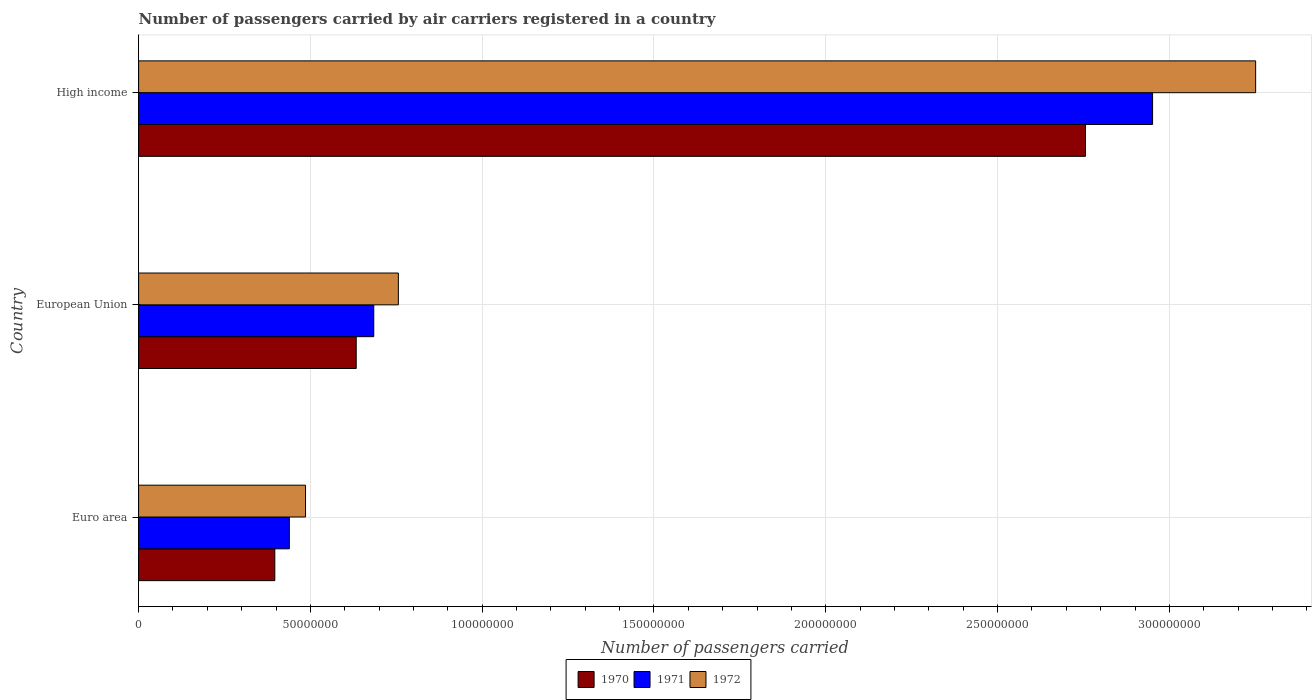How many groups of bars are there?
Provide a succinct answer. 3. Are the number of bars on each tick of the Y-axis equal?
Provide a succinct answer. Yes. How many bars are there on the 2nd tick from the top?
Give a very brief answer. 3. How many bars are there on the 3rd tick from the bottom?
Make the answer very short. 3. What is the label of the 2nd group of bars from the top?
Your answer should be compact. European Union. In how many cases, is the number of bars for a given country not equal to the number of legend labels?
Give a very brief answer. 0. What is the number of passengers carried by air carriers in 1972 in High income?
Ensure brevity in your answer.  3.25e+08. Across all countries, what is the maximum number of passengers carried by air carriers in 1972?
Provide a succinct answer. 3.25e+08. Across all countries, what is the minimum number of passengers carried by air carriers in 1971?
Your response must be concise. 4.39e+07. In which country was the number of passengers carried by air carriers in 1972 maximum?
Your answer should be very brief. High income. In which country was the number of passengers carried by air carriers in 1970 minimum?
Your response must be concise. Euro area. What is the total number of passengers carried by air carriers in 1970 in the graph?
Provide a succinct answer. 3.79e+08. What is the difference between the number of passengers carried by air carriers in 1971 in Euro area and that in High income?
Offer a very short reply. -2.51e+08. What is the difference between the number of passengers carried by air carriers in 1972 in European Union and the number of passengers carried by air carriers in 1971 in High income?
Ensure brevity in your answer.  -2.20e+08. What is the average number of passengers carried by air carriers in 1971 per country?
Provide a succinct answer. 1.36e+08. What is the difference between the number of passengers carried by air carriers in 1970 and number of passengers carried by air carriers in 1971 in High income?
Give a very brief answer. -1.95e+07. What is the ratio of the number of passengers carried by air carriers in 1971 in Euro area to that in High income?
Make the answer very short. 0.15. Is the number of passengers carried by air carriers in 1972 in European Union less than that in High income?
Your answer should be compact. Yes. What is the difference between the highest and the second highest number of passengers carried by air carriers in 1972?
Provide a succinct answer. 2.50e+08. What is the difference between the highest and the lowest number of passengers carried by air carriers in 1971?
Provide a short and direct response. 2.51e+08. What does the 1st bar from the top in Euro area represents?
Give a very brief answer. 1972. What does the 2nd bar from the bottom in High income represents?
Your response must be concise. 1971. Is it the case that in every country, the sum of the number of passengers carried by air carriers in 1970 and number of passengers carried by air carriers in 1972 is greater than the number of passengers carried by air carriers in 1971?
Provide a succinct answer. Yes. Does the graph contain grids?
Provide a succinct answer. Yes. How many legend labels are there?
Your response must be concise. 3. What is the title of the graph?
Your response must be concise. Number of passengers carried by air carriers registered in a country. Does "1983" appear as one of the legend labels in the graph?
Your answer should be compact. No. What is the label or title of the X-axis?
Keep it short and to the point. Number of passengers carried. What is the Number of passengers carried of 1970 in Euro area?
Offer a terse response. 3.96e+07. What is the Number of passengers carried of 1971 in Euro area?
Provide a succinct answer. 4.39e+07. What is the Number of passengers carried of 1972 in Euro area?
Keep it short and to the point. 4.86e+07. What is the Number of passengers carried in 1970 in European Union?
Give a very brief answer. 6.33e+07. What is the Number of passengers carried in 1971 in European Union?
Provide a succinct answer. 6.84e+07. What is the Number of passengers carried of 1972 in European Union?
Your answer should be very brief. 7.56e+07. What is the Number of passengers carried in 1970 in High income?
Keep it short and to the point. 2.76e+08. What is the Number of passengers carried of 1971 in High income?
Provide a succinct answer. 2.95e+08. What is the Number of passengers carried in 1972 in High income?
Offer a terse response. 3.25e+08. Across all countries, what is the maximum Number of passengers carried in 1970?
Provide a short and direct response. 2.76e+08. Across all countries, what is the maximum Number of passengers carried of 1971?
Ensure brevity in your answer.  2.95e+08. Across all countries, what is the maximum Number of passengers carried of 1972?
Offer a very short reply. 3.25e+08. Across all countries, what is the minimum Number of passengers carried in 1970?
Keep it short and to the point. 3.96e+07. Across all countries, what is the minimum Number of passengers carried of 1971?
Give a very brief answer. 4.39e+07. Across all countries, what is the minimum Number of passengers carried in 1972?
Provide a succinct answer. 4.86e+07. What is the total Number of passengers carried of 1970 in the graph?
Your answer should be compact. 3.79e+08. What is the total Number of passengers carried of 1971 in the graph?
Your response must be concise. 4.07e+08. What is the total Number of passengers carried of 1972 in the graph?
Give a very brief answer. 4.49e+08. What is the difference between the Number of passengers carried of 1970 in Euro area and that in European Union?
Your answer should be very brief. -2.37e+07. What is the difference between the Number of passengers carried in 1971 in Euro area and that in European Union?
Give a very brief answer. -2.46e+07. What is the difference between the Number of passengers carried in 1972 in Euro area and that in European Union?
Offer a very short reply. -2.70e+07. What is the difference between the Number of passengers carried in 1970 in Euro area and that in High income?
Make the answer very short. -2.36e+08. What is the difference between the Number of passengers carried of 1971 in Euro area and that in High income?
Offer a very short reply. -2.51e+08. What is the difference between the Number of passengers carried in 1972 in Euro area and that in High income?
Your answer should be compact. -2.77e+08. What is the difference between the Number of passengers carried of 1970 in European Union and that in High income?
Your answer should be compact. -2.12e+08. What is the difference between the Number of passengers carried of 1971 in European Union and that in High income?
Your response must be concise. -2.27e+08. What is the difference between the Number of passengers carried of 1972 in European Union and that in High income?
Offer a very short reply. -2.50e+08. What is the difference between the Number of passengers carried of 1970 in Euro area and the Number of passengers carried of 1971 in European Union?
Offer a terse response. -2.88e+07. What is the difference between the Number of passengers carried in 1970 in Euro area and the Number of passengers carried in 1972 in European Union?
Ensure brevity in your answer.  -3.60e+07. What is the difference between the Number of passengers carried in 1971 in Euro area and the Number of passengers carried in 1972 in European Union?
Give a very brief answer. -3.17e+07. What is the difference between the Number of passengers carried in 1970 in Euro area and the Number of passengers carried in 1971 in High income?
Ensure brevity in your answer.  -2.55e+08. What is the difference between the Number of passengers carried of 1970 in Euro area and the Number of passengers carried of 1972 in High income?
Your answer should be very brief. -2.85e+08. What is the difference between the Number of passengers carried of 1971 in Euro area and the Number of passengers carried of 1972 in High income?
Provide a succinct answer. -2.81e+08. What is the difference between the Number of passengers carried in 1970 in European Union and the Number of passengers carried in 1971 in High income?
Keep it short and to the point. -2.32e+08. What is the difference between the Number of passengers carried in 1970 in European Union and the Number of passengers carried in 1972 in High income?
Your answer should be very brief. -2.62e+08. What is the difference between the Number of passengers carried in 1971 in European Union and the Number of passengers carried in 1972 in High income?
Your answer should be compact. -2.57e+08. What is the average Number of passengers carried in 1970 per country?
Offer a terse response. 1.26e+08. What is the average Number of passengers carried in 1971 per country?
Give a very brief answer. 1.36e+08. What is the average Number of passengers carried of 1972 per country?
Offer a very short reply. 1.50e+08. What is the difference between the Number of passengers carried of 1970 and Number of passengers carried of 1971 in Euro area?
Keep it short and to the point. -4.23e+06. What is the difference between the Number of passengers carried in 1970 and Number of passengers carried in 1972 in Euro area?
Keep it short and to the point. -8.94e+06. What is the difference between the Number of passengers carried of 1971 and Number of passengers carried of 1972 in Euro area?
Keep it short and to the point. -4.71e+06. What is the difference between the Number of passengers carried of 1970 and Number of passengers carried of 1971 in European Union?
Keep it short and to the point. -5.11e+06. What is the difference between the Number of passengers carried in 1970 and Number of passengers carried in 1972 in European Union?
Provide a succinct answer. -1.23e+07. What is the difference between the Number of passengers carried of 1971 and Number of passengers carried of 1972 in European Union?
Your answer should be compact. -7.16e+06. What is the difference between the Number of passengers carried of 1970 and Number of passengers carried of 1971 in High income?
Give a very brief answer. -1.95e+07. What is the difference between the Number of passengers carried in 1970 and Number of passengers carried in 1972 in High income?
Your answer should be very brief. -4.95e+07. What is the difference between the Number of passengers carried of 1971 and Number of passengers carried of 1972 in High income?
Offer a very short reply. -3.00e+07. What is the ratio of the Number of passengers carried of 1970 in Euro area to that in European Union?
Ensure brevity in your answer.  0.63. What is the ratio of the Number of passengers carried in 1971 in Euro area to that in European Union?
Make the answer very short. 0.64. What is the ratio of the Number of passengers carried in 1972 in Euro area to that in European Union?
Your response must be concise. 0.64. What is the ratio of the Number of passengers carried of 1970 in Euro area to that in High income?
Make the answer very short. 0.14. What is the ratio of the Number of passengers carried of 1971 in Euro area to that in High income?
Keep it short and to the point. 0.15. What is the ratio of the Number of passengers carried in 1972 in Euro area to that in High income?
Ensure brevity in your answer.  0.15. What is the ratio of the Number of passengers carried in 1970 in European Union to that in High income?
Keep it short and to the point. 0.23. What is the ratio of the Number of passengers carried of 1971 in European Union to that in High income?
Provide a succinct answer. 0.23. What is the ratio of the Number of passengers carried in 1972 in European Union to that in High income?
Your response must be concise. 0.23. What is the difference between the highest and the second highest Number of passengers carried of 1970?
Keep it short and to the point. 2.12e+08. What is the difference between the highest and the second highest Number of passengers carried in 1971?
Offer a terse response. 2.27e+08. What is the difference between the highest and the second highest Number of passengers carried of 1972?
Ensure brevity in your answer.  2.50e+08. What is the difference between the highest and the lowest Number of passengers carried of 1970?
Ensure brevity in your answer.  2.36e+08. What is the difference between the highest and the lowest Number of passengers carried in 1971?
Give a very brief answer. 2.51e+08. What is the difference between the highest and the lowest Number of passengers carried in 1972?
Make the answer very short. 2.77e+08. 